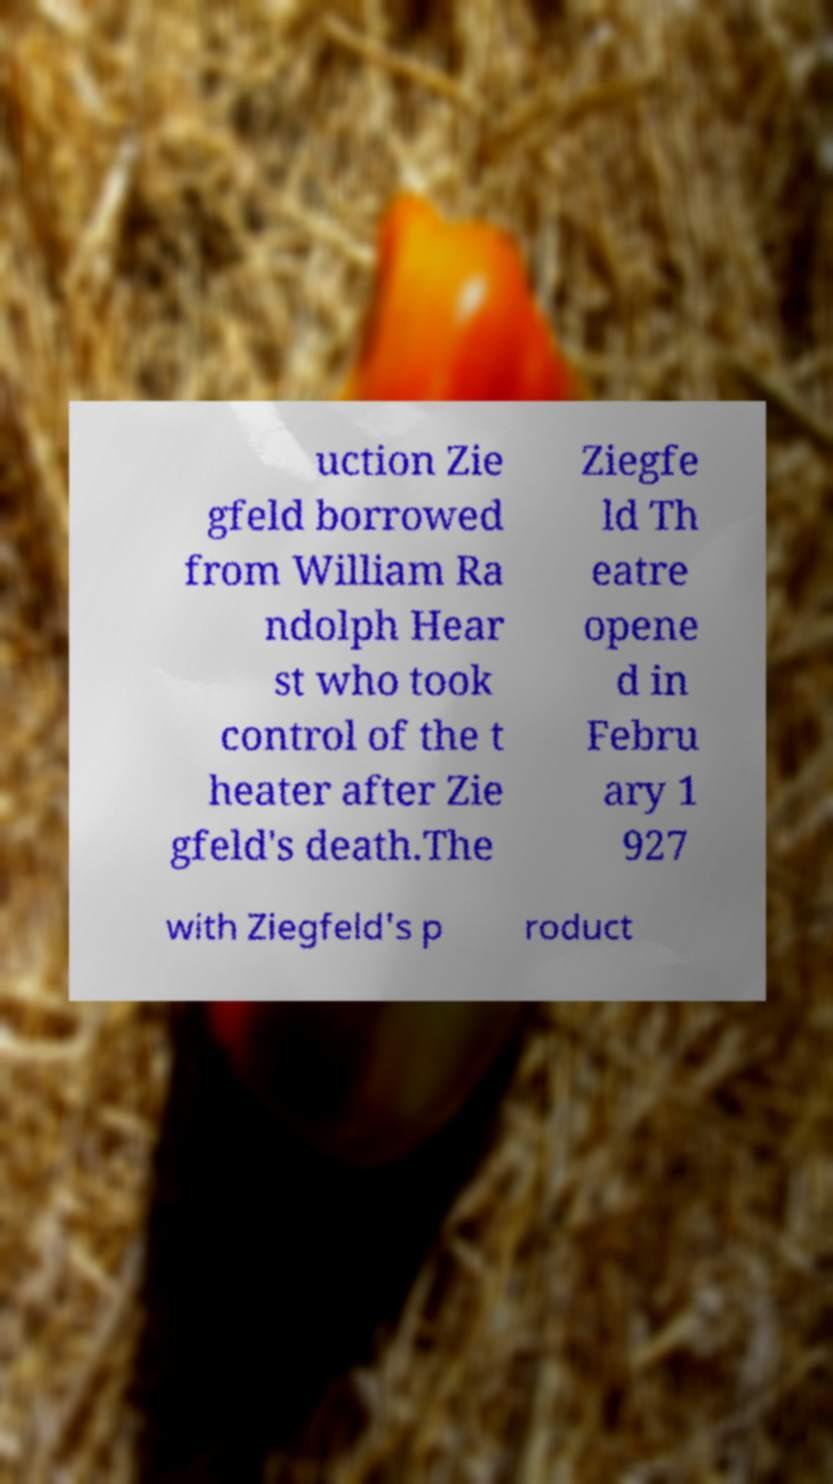Could you extract and type out the text from this image? uction Zie gfeld borrowed from William Ra ndolph Hear st who took control of the t heater after Zie gfeld's death.The Ziegfe ld Th eatre opene d in Febru ary 1 927 with Ziegfeld's p roduct 